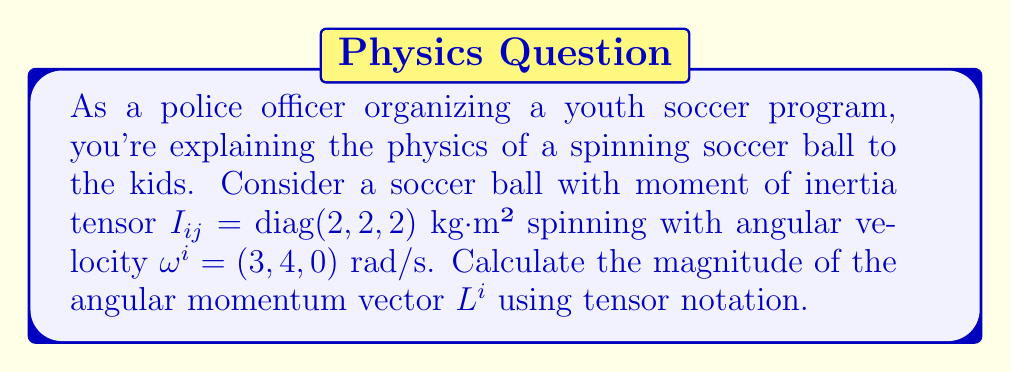Show me your answer to this math problem. Let's approach this step-by-step:

1) The angular momentum vector $L^i$ is related to the angular velocity vector $\omega^j$ by the moment of inertia tensor $I_{ij}$:

   $$L^i = I_{ij}\omega^j$$

2) Given:
   - Moment of inertia tensor: $I_{ij} = \text{diag}(2, 2, 2)$ kg·m²
   - Angular velocity vector: $\omega^i = (3, 4, 0)$ rad/s

3) Expand the equation using Einstein summation convention:

   $$L^i = I_{i1}\omega^1 + I_{i2}\omega^2 + I_{i3}\omega^3$$

4) Calculate each component of $L^i$:

   $L^1 = 2 \cdot 3 + 0 \cdot 4 + 0 \cdot 0 = 6$ kg·m²/s
   $L^2 = 0 \cdot 3 + 2 \cdot 4 + 0 \cdot 0 = 8$ kg·m²/s
   $L^3 = 0 \cdot 3 + 0 \cdot 4 + 2 \cdot 0 = 0$ kg·m²/s

5) So, $L^i = (6, 8, 0)$ kg·m²/s

6) The magnitude of $L^i$ is given by:

   $$|L| = \sqrt{(L^1)^2 + (L^2)^2 + (L^3)^2}$$

7) Substitute the values:

   $$|L| = \sqrt{6^2 + 8^2 + 0^2} = \sqrt{36 + 64 + 0} = \sqrt{100} = 10$$ kg·m²/s
Answer: $10$ kg·m²/s 